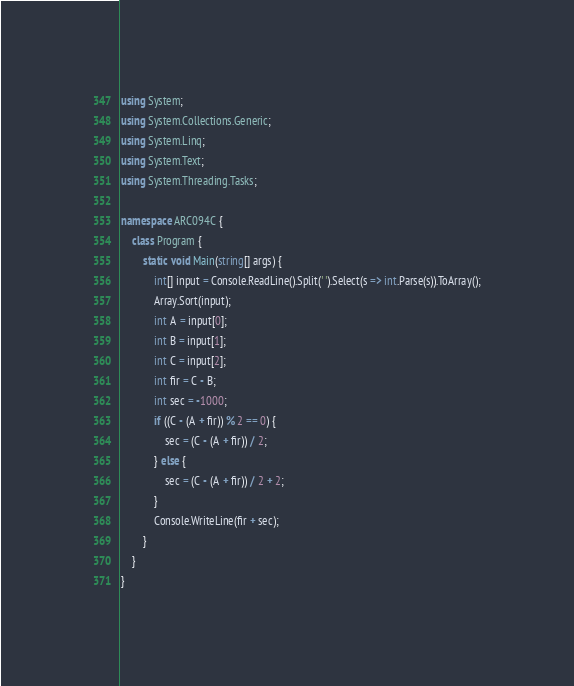<code> <loc_0><loc_0><loc_500><loc_500><_C#_>using System;
using System.Collections.Generic;
using System.Linq;
using System.Text;
using System.Threading.Tasks;

namespace ARC094C {
    class Program {
        static void Main(string[] args) {
            int[] input = Console.ReadLine().Split(' ').Select(s => int.Parse(s)).ToArray();
            Array.Sort(input);
            int A = input[0];
            int B = input[1];
            int C = input[2];
            int fir = C - B;
            int sec = -1000;
            if ((C - (A + fir)) % 2 == 0) {
                sec = (C - (A + fir)) / 2;
            } else {
                sec = (C - (A + fir)) / 2 + 2;
            }
            Console.WriteLine(fir + sec);
        }
    }
}
</code> 